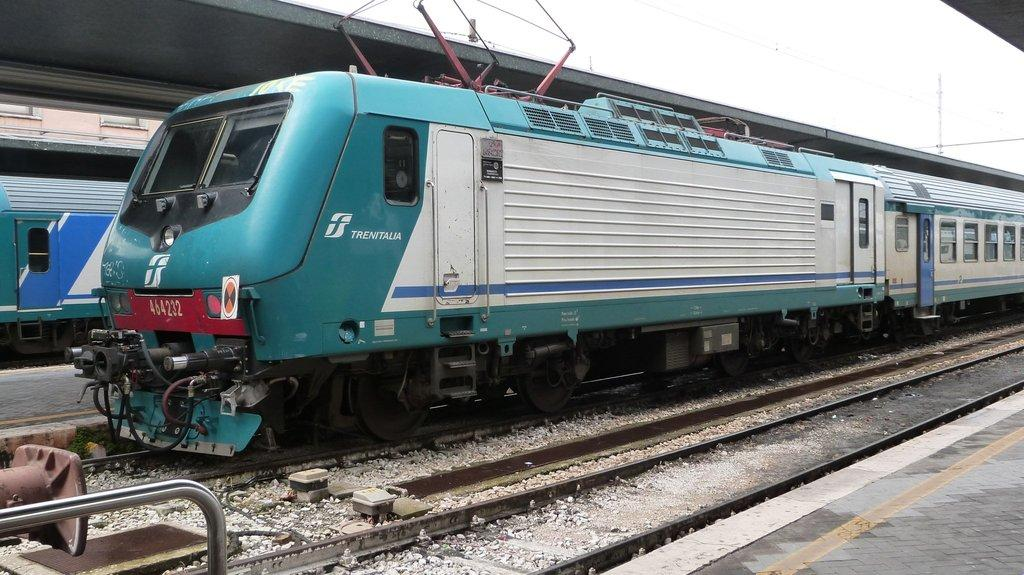<image>
Give a short and clear explanation of the subsequent image. A Trenitalia train has an ID number on he front car of 464232. 